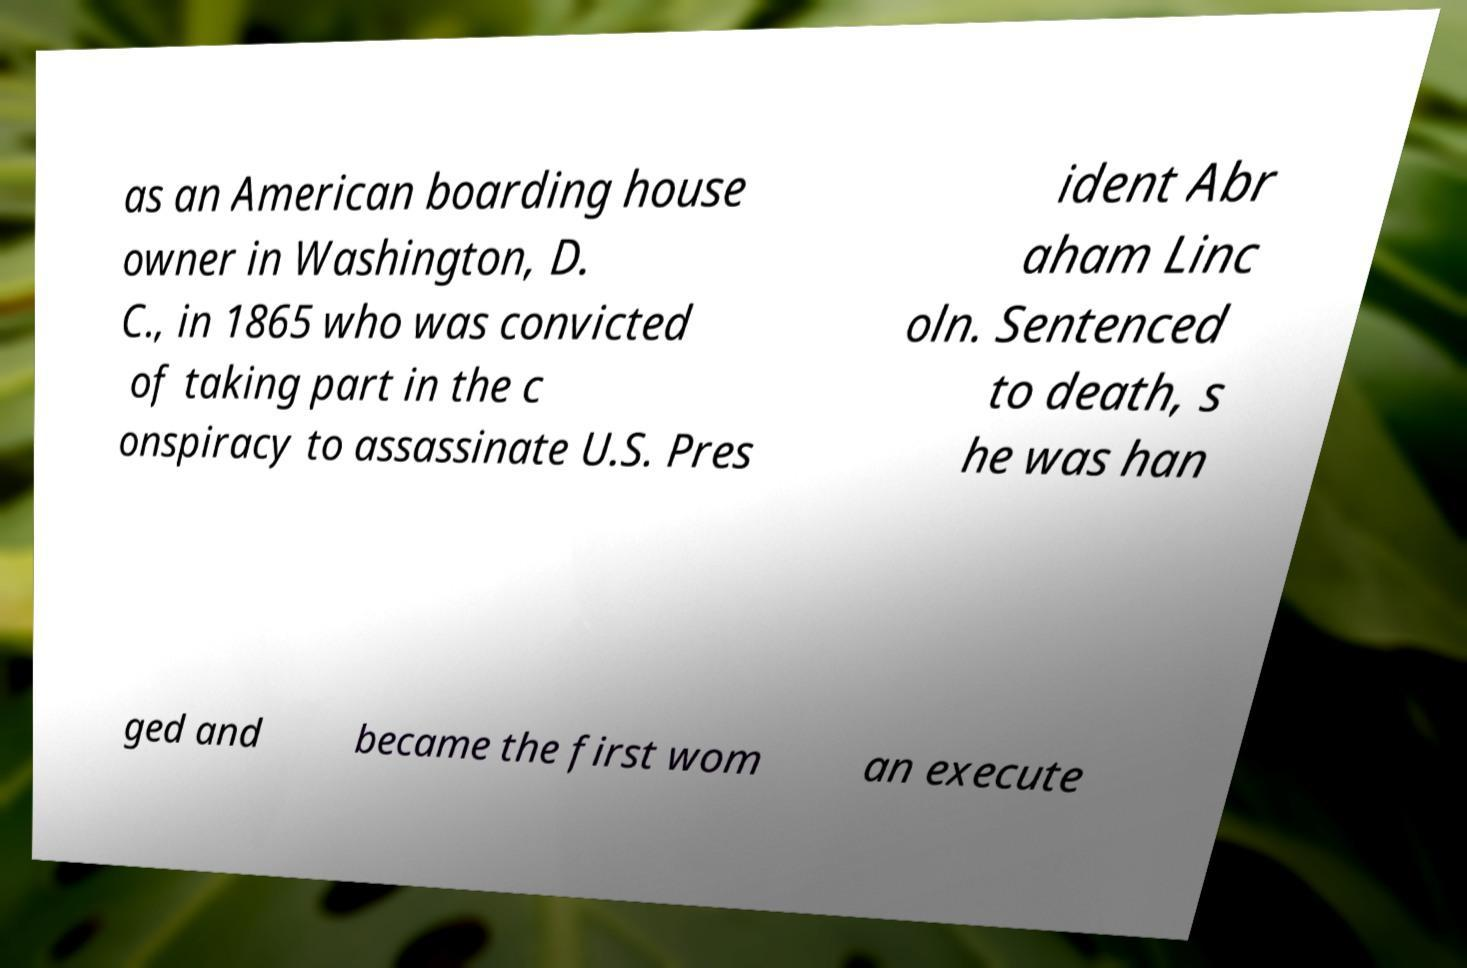Can you accurately transcribe the text from the provided image for me? as an American boarding house owner in Washington, D. C., in 1865 who was convicted of taking part in the c onspiracy to assassinate U.S. Pres ident Abr aham Linc oln. Sentenced to death, s he was han ged and became the first wom an execute 